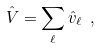Convert formula to latex. <formula><loc_0><loc_0><loc_500><loc_500>\hat { V } = \sum _ { \ell } \hat { v } _ { \ell } \ ,</formula> 